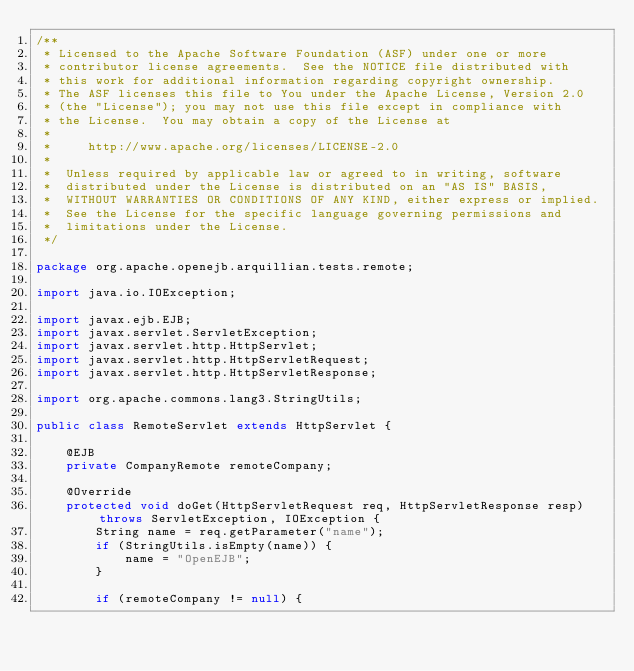<code> <loc_0><loc_0><loc_500><loc_500><_Java_>/**
 * Licensed to the Apache Software Foundation (ASF) under one or more
 * contributor license agreements.  See the NOTICE file distributed with
 * this work for additional information regarding copyright ownership.
 * The ASF licenses this file to You under the Apache License, Version 2.0
 * (the "License"); you may not use this file except in compliance with
 * the License.  You may obtain a copy of the License at
 *
 *     http://www.apache.org/licenses/LICENSE-2.0
 *
 *  Unless required by applicable law or agreed to in writing, software
 *  distributed under the License is distributed on an "AS IS" BASIS,
 *  WITHOUT WARRANTIES OR CONDITIONS OF ANY KIND, either express or implied.
 *  See the License for the specific language governing permissions and
 *  limitations under the License.
 */

package org.apache.openejb.arquillian.tests.remote;

import java.io.IOException;

import javax.ejb.EJB;
import javax.servlet.ServletException;
import javax.servlet.http.HttpServlet;
import javax.servlet.http.HttpServletRequest;
import javax.servlet.http.HttpServletResponse;

import org.apache.commons.lang3.StringUtils;

public class RemoteServlet extends HttpServlet {

    @EJB
    private CompanyRemote remoteCompany;

    @Override
    protected void doGet(HttpServletRequest req, HttpServletResponse resp) throws ServletException, IOException {
        String name = req.getParameter("name");
        if (StringUtils.isEmpty(name)) {
            name = "OpenEJB";
        }

        if (remoteCompany != null) {</code> 